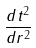Convert formula to latex. <formula><loc_0><loc_0><loc_500><loc_500>\frac { d t ^ { 2 } } { d r ^ { 2 } }</formula> 